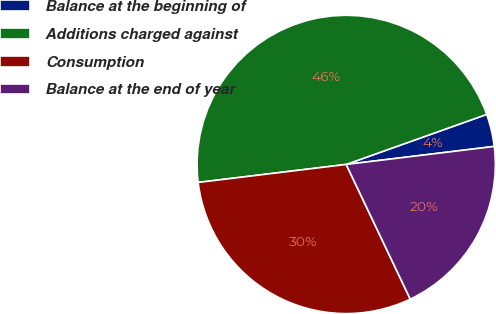Convert chart. <chart><loc_0><loc_0><loc_500><loc_500><pie_chart><fcel>Balance at the beginning of<fcel>Additions charged against<fcel>Consumption<fcel>Balance at the end of year<nl><fcel>3.52%<fcel>46.48%<fcel>30.14%<fcel>19.86%<nl></chart> 